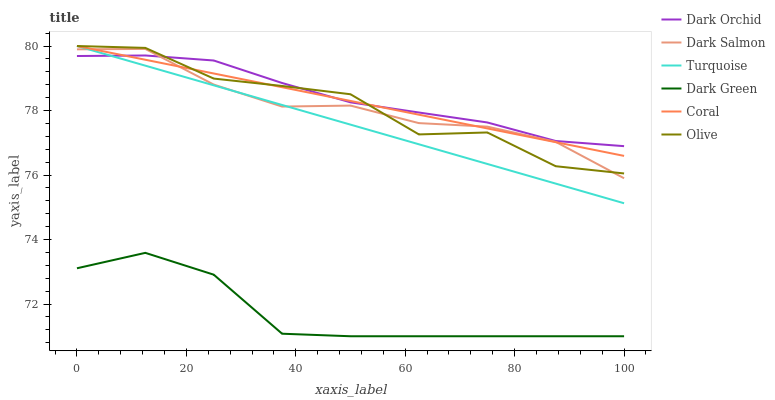Does Coral have the minimum area under the curve?
Answer yes or no. No. Does Coral have the maximum area under the curve?
Answer yes or no. No. Is Dark Salmon the smoothest?
Answer yes or no. No. Is Dark Salmon the roughest?
Answer yes or no. No. Does Coral have the lowest value?
Answer yes or no. No. Does Dark Salmon have the highest value?
Answer yes or no. No. Is Dark Green less than Dark Salmon?
Answer yes or no. Yes. Is Dark Salmon greater than Dark Green?
Answer yes or no. Yes. Does Dark Green intersect Dark Salmon?
Answer yes or no. No. 